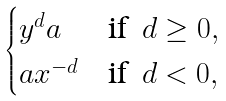Convert formula to latex. <formula><loc_0><loc_0><loc_500><loc_500>\begin{cases} y ^ { d } a & \text {if } \, d \geq 0 , \\ a x ^ { - d } & \text {if } \, d < 0 , \\ \end{cases}</formula> 